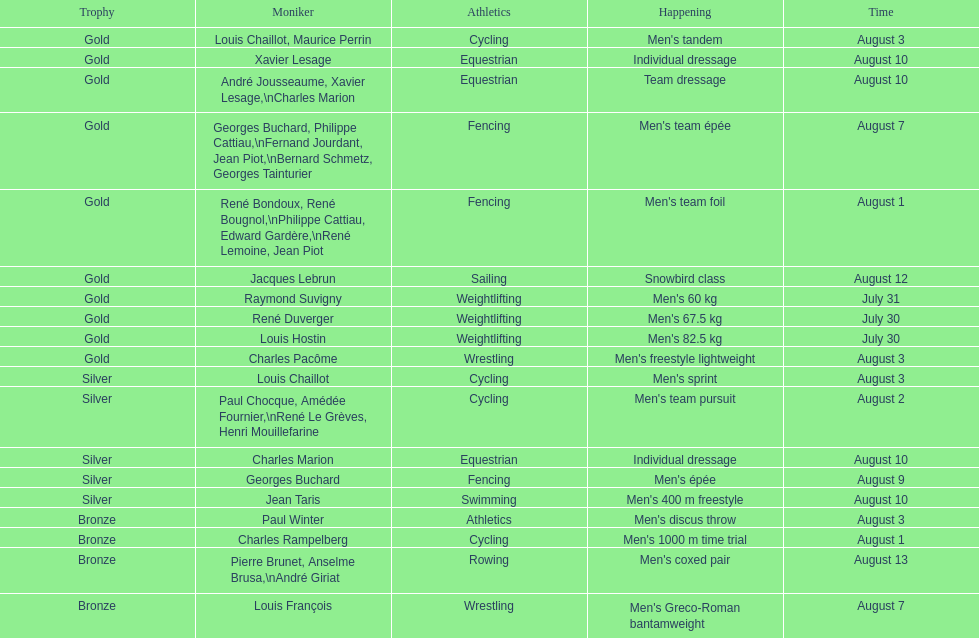What sport is listed first? Cycling. 